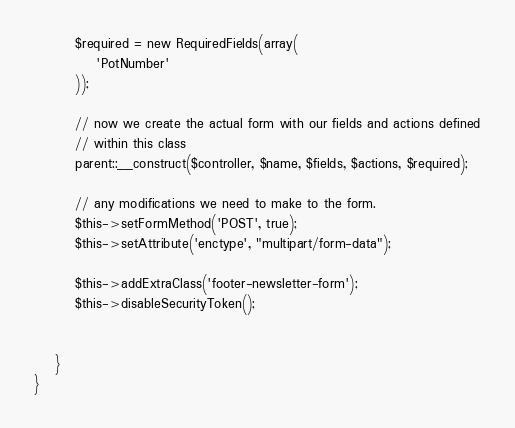Convert code to text. <code><loc_0><loc_0><loc_500><loc_500><_PHP_>        $required = new RequiredFields(array(
            'PotNumber'
        ));

        // now we create the actual form with our fields and actions defined
        // within this class
        parent::__construct($controller, $name, $fields, $actions, $required);

        // any modifications we need to make to the form.
        $this->setFormMethod('POST', true);
        $this->setAttribute('enctype', "multipart/form-data");

        $this->addExtraClass('footer-newsletter-form');
        $this->disableSecurityToken();


    }
}
</code> 